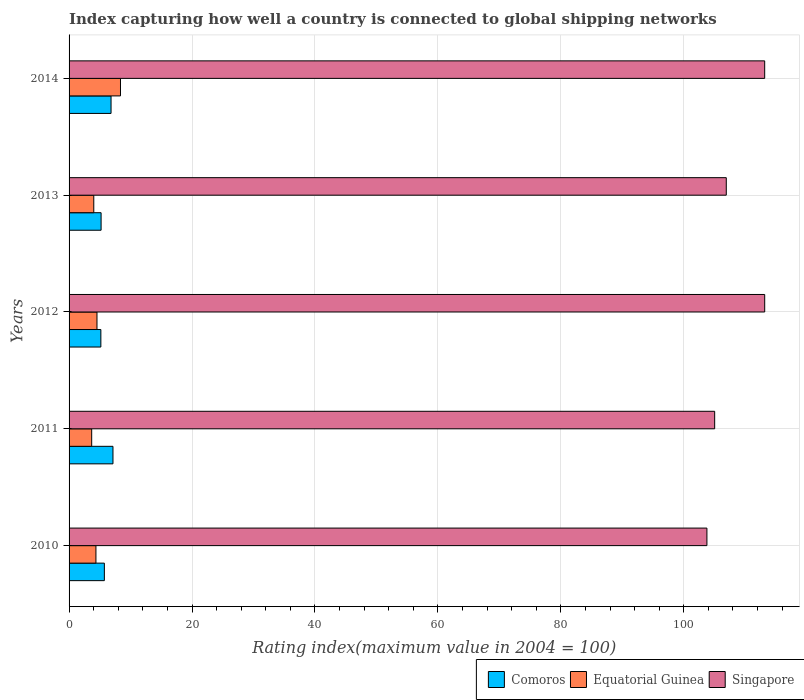How many different coloured bars are there?
Your answer should be compact. 3. Are the number of bars per tick equal to the number of legend labels?
Your answer should be very brief. Yes. How many bars are there on the 5th tick from the bottom?
Offer a very short reply. 3. What is the label of the 3rd group of bars from the top?
Provide a succinct answer. 2012. What is the rating index in Comoros in 2012?
Your answer should be compact. 5.17. Across all years, what is the maximum rating index in Singapore?
Give a very brief answer. 113.16. Across all years, what is the minimum rating index in Singapore?
Ensure brevity in your answer.  103.76. What is the total rating index in Singapore in the graph?
Ensure brevity in your answer.  542.01. What is the difference between the rating index in Comoros in 2010 and that in 2014?
Give a very brief answer. -1.09. What is the difference between the rating index in Equatorial Guinea in 2010 and the rating index in Singapore in 2014?
Make the answer very short. -108.79. What is the average rating index in Equatorial Guinea per year?
Your answer should be very brief. 4.99. In the year 2013, what is the difference between the rating index in Equatorial Guinea and rating index in Comoros?
Make the answer very short. -1.19. What is the ratio of the rating index in Comoros in 2010 to that in 2014?
Ensure brevity in your answer.  0.84. Is the difference between the rating index in Equatorial Guinea in 2011 and 2014 greater than the difference between the rating index in Comoros in 2011 and 2014?
Keep it short and to the point. No. What is the difference between the highest and the second highest rating index in Singapore?
Give a very brief answer. 0. What is the difference between the highest and the lowest rating index in Equatorial Guinea?
Make the answer very short. 4.68. In how many years, is the rating index in Comoros greater than the average rating index in Comoros taken over all years?
Make the answer very short. 2. Is the sum of the rating index in Equatorial Guinea in 2010 and 2011 greater than the maximum rating index in Singapore across all years?
Your answer should be compact. No. What does the 1st bar from the top in 2013 represents?
Offer a very short reply. Singapore. What does the 1st bar from the bottom in 2014 represents?
Offer a very short reply. Comoros. Is it the case that in every year, the sum of the rating index in Singapore and rating index in Equatorial Guinea is greater than the rating index in Comoros?
Provide a succinct answer. Yes. How many bars are there?
Your answer should be very brief. 15. What is the difference between two consecutive major ticks on the X-axis?
Your answer should be compact. 20. How are the legend labels stacked?
Offer a very short reply. Horizontal. What is the title of the graph?
Offer a terse response. Index capturing how well a country is connected to global shipping networks. What is the label or title of the X-axis?
Give a very brief answer. Rating index(maximum value in 2004 = 100). What is the Rating index(maximum value in 2004 = 100) of Comoros in 2010?
Your response must be concise. 5.74. What is the Rating index(maximum value in 2004 = 100) in Equatorial Guinea in 2010?
Provide a succinct answer. 4.37. What is the Rating index(maximum value in 2004 = 100) of Singapore in 2010?
Provide a short and direct response. 103.76. What is the Rating index(maximum value in 2004 = 100) of Comoros in 2011?
Ensure brevity in your answer.  7.14. What is the Rating index(maximum value in 2004 = 100) of Equatorial Guinea in 2011?
Your response must be concise. 3.68. What is the Rating index(maximum value in 2004 = 100) in Singapore in 2011?
Offer a terse response. 105.02. What is the Rating index(maximum value in 2004 = 100) of Comoros in 2012?
Make the answer very short. 5.17. What is the Rating index(maximum value in 2004 = 100) in Equatorial Guinea in 2012?
Make the answer very short. 4.54. What is the Rating index(maximum value in 2004 = 100) of Singapore in 2012?
Make the answer very short. 113.16. What is the Rating index(maximum value in 2004 = 100) of Comoros in 2013?
Provide a short and direct response. 5.21. What is the Rating index(maximum value in 2004 = 100) in Equatorial Guinea in 2013?
Your answer should be compact. 4.02. What is the Rating index(maximum value in 2004 = 100) in Singapore in 2013?
Your answer should be compact. 106.91. What is the Rating index(maximum value in 2004 = 100) of Comoros in 2014?
Keep it short and to the point. 6.83. What is the Rating index(maximum value in 2004 = 100) in Equatorial Guinea in 2014?
Keep it short and to the point. 8.36. What is the Rating index(maximum value in 2004 = 100) of Singapore in 2014?
Make the answer very short. 113.16. Across all years, what is the maximum Rating index(maximum value in 2004 = 100) in Comoros?
Ensure brevity in your answer.  7.14. Across all years, what is the maximum Rating index(maximum value in 2004 = 100) of Equatorial Guinea?
Make the answer very short. 8.36. Across all years, what is the maximum Rating index(maximum value in 2004 = 100) of Singapore?
Your answer should be very brief. 113.16. Across all years, what is the minimum Rating index(maximum value in 2004 = 100) in Comoros?
Your answer should be very brief. 5.17. Across all years, what is the minimum Rating index(maximum value in 2004 = 100) in Equatorial Guinea?
Provide a short and direct response. 3.68. Across all years, what is the minimum Rating index(maximum value in 2004 = 100) of Singapore?
Your answer should be compact. 103.76. What is the total Rating index(maximum value in 2004 = 100) of Comoros in the graph?
Provide a short and direct response. 30.09. What is the total Rating index(maximum value in 2004 = 100) in Equatorial Guinea in the graph?
Make the answer very short. 24.97. What is the total Rating index(maximum value in 2004 = 100) of Singapore in the graph?
Your answer should be compact. 542.01. What is the difference between the Rating index(maximum value in 2004 = 100) in Equatorial Guinea in 2010 and that in 2011?
Provide a succinct answer. 0.69. What is the difference between the Rating index(maximum value in 2004 = 100) in Singapore in 2010 and that in 2011?
Ensure brevity in your answer.  -1.26. What is the difference between the Rating index(maximum value in 2004 = 100) in Comoros in 2010 and that in 2012?
Your answer should be compact. 0.57. What is the difference between the Rating index(maximum value in 2004 = 100) of Equatorial Guinea in 2010 and that in 2012?
Keep it short and to the point. -0.17. What is the difference between the Rating index(maximum value in 2004 = 100) of Comoros in 2010 and that in 2013?
Your response must be concise. 0.53. What is the difference between the Rating index(maximum value in 2004 = 100) of Equatorial Guinea in 2010 and that in 2013?
Provide a succinct answer. 0.35. What is the difference between the Rating index(maximum value in 2004 = 100) of Singapore in 2010 and that in 2013?
Ensure brevity in your answer.  -3.15. What is the difference between the Rating index(maximum value in 2004 = 100) in Comoros in 2010 and that in 2014?
Offer a very short reply. -1.09. What is the difference between the Rating index(maximum value in 2004 = 100) of Equatorial Guinea in 2010 and that in 2014?
Ensure brevity in your answer.  -3.99. What is the difference between the Rating index(maximum value in 2004 = 100) of Singapore in 2010 and that in 2014?
Give a very brief answer. -9.4. What is the difference between the Rating index(maximum value in 2004 = 100) in Comoros in 2011 and that in 2012?
Your response must be concise. 1.97. What is the difference between the Rating index(maximum value in 2004 = 100) in Equatorial Guinea in 2011 and that in 2012?
Provide a short and direct response. -0.86. What is the difference between the Rating index(maximum value in 2004 = 100) in Singapore in 2011 and that in 2012?
Make the answer very short. -8.14. What is the difference between the Rating index(maximum value in 2004 = 100) of Comoros in 2011 and that in 2013?
Offer a terse response. 1.93. What is the difference between the Rating index(maximum value in 2004 = 100) in Equatorial Guinea in 2011 and that in 2013?
Provide a succinct answer. -0.34. What is the difference between the Rating index(maximum value in 2004 = 100) of Singapore in 2011 and that in 2013?
Offer a terse response. -1.89. What is the difference between the Rating index(maximum value in 2004 = 100) of Comoros in 2011 and that in 2014?
Your answer should be compact. 0.31. What is the difference between the Rating index(maximum value in 2004 = 100) of Equatorial Guinea in 2011 and that in 2014?
Make the answer very short. -4.68. What is the difference between the Rating index(maximum value in 2004 = 100) of Singapore in 2011 and that in 2014?
Give a very brief answer. -8.14. What is the difference between the Rating index(maximum value in 2004 = 100) in Comoros in 2012 and that in 2013?
Your answer should be very brief. -0.04. What is the difference between the Rating index(maximum value in 2004 = 100) of Equatorial Guinea in 2012 and that in 2013?
Offer a terse response. 0.52. What is the difference between the Rating index(maximum value in 2004 = 100) in Singapore in 2012 and that in 2013?
Keep it short and to the point. 6.25. What is the difference between the Rating index(maximum value in 2004 = 100) of Comoros in 2012 and that in 2014?
Your answer should be very brief. -1.66. What is the difference between the Rating index(maximum value in 2004 = 100) of Equatorial Guinea in 2012 and that in 2014?
Provide a short and direct response. -3.82. What is the difference between the Rating index(maximum value in 2004 = 100) of Singapore in 2012 and that in 2014?
Your response must be concise. 0. What is the difference between the Rating index(maximum value in 2004 = 100) in Comoros in 2013 and that in 2014?
Your response must be concise. -1.62. What is the difference between the Rating index(maximum value in 2004 = 100) in Equatorial Guinea in 2013 and that in 2014?
Provide a short and direct response. -4.34. What is the difference between the Rating index(maximum value in 2004 = 100) in Singapore in 2013 and that in 2014?
Make the answer very short. -6.25. What is the difference between the Rating index(maximum value in 2004 = 100) in Comoros in 2010 and the Rating index(maximum value in 2004 = 100) in Equatorial Guinea in 2011?
Make the answer very short. 2.06. What is the difference between the Rating index(maximum value in 2004 = 100) of Comoros in 2010 and the Rating index(maximum value in 2004 = 100) of Singapore in 2011?
Ensure brevity in your answer.  -99.28. What is the difference between the Rating index(maximum value in 2004 = 100) in Equatorial Guinea in 2010 and the Rating index(maximum value in 2004 = 100) in Singapore in 2011?
Make the answer very short. -100.65. What is the difference between the Rating index(maximum value in 2004 = 100) of Comoros in 2010 and the Rating index(maximum value in 2004 = 100) of Equatorial Guinea in 2012?
Your answer should be very brief. 1.2. What is the difference between the Rating index(maximum value in 2004 = 100) of Comoros in 2010 and the Rating index(maximum value in 2004 = 100) of Singapore in 2012?
Ensure brevity in your answer.  -107.42. What is the difference between the Rating index(maximum value in 2004 = 100) in Equatorial Guinea in 2010 and the Rating index(maximum value in 2004 = 100) in Singapore in 2012?
Keep it short and to the point. -108.79. What is the difference between the Rating index(maximum value in 2004 = 100) in Comoros in 2010 and the Rating index(maximum value in 2004 = 100) in Equatorial Guinea in 2013?
Offer a very short reply. 1.72. What is the difference between the Rating index(maximum value in 2004 = 100) in Comoros in 2010 and the Rating index(maximum value in 2004 = 100) in Singapore in 2013?
Your response must be concise. -101.17. What is the difference between the Rating index(maximum value in 2004 = 100) in Equatorial Guinea in 2010 and the Rating index(maximum value in 2004 = 100) in Singapore in 2013?
Ensure brevity in your answer.  -102.54. What is the difference between the Rating index(maximum value in 2004 = 100) of Comoros in 2010 and the Rating index(maximum value in 2004 = 100) of Equatorial Guinea in 2014?
Give a very brief answer. -2.62. What is the difference between the Rating index(maximum value in 2004 = 100) in Comoros in 2010 and the Rating index(maximum value in 2004 = 100) in Singapore in 2014?
Offer a very short reply. -107.42. What is the difference between the Rating index(maximum value in 2004 = 100) in Equatorial Guinea in 2010 and the Rating index(maximum value in 2004 = 100) in Singapore in 2014?
Give a very brief answer. -108.79. What is the difference between the Rating index(maximum value in 2004 = 100) of Comoros in 2011 and the Rating index(maximum value in 2004 = 100) of Equatorial Guinea in 2012?
Your answer should be compact. 2.6. What is the difference between the Rating index(maximum value in 2004 = 100) in Comoros in 2011 and the Rating index(maximum value in 2004 = 100) in Singapore in 2012?
Offer a terse response. -106.02. What is the difference between the Rating index(maximum value in 2004 = 100) of Equatorial Guinea in 2011 and the Rating index(maximum value in 2004 = 100) of Singapore in 2012?
Give a very brief answer. -109.48. What is the difference between the Rating index(maximum value in 2004 = 100) of Comoros in 2011 and the Rating index(maximum value in 2004 = 100) of Equatorial Guinea in 2013?
Provide a succinct answer. 3.12. What is the difference between the Rating index(maximum value in 2004 = 100) of Comoros in 2011 and the Rating index(maximum value in 2004 = 100) of Singapore in 2013?
Your response must be concise. -99.77. What is the difference between the Rating index(maximum value in 2004 = 100) in Equatorial Guinea in 2011 and the Rating index(maximum value in 2004 = 100) in Singapore in 2013?
Offer a very short reply. -103.23. What is the difference between the Rating index(maximum value in 2004 = 100) of Comoros in 2011 and the Rating index(maximum value in 2004 = 100) of Equatorial Guinea in 2014?
Your response must be concise. -1.22. What is the difference between the Rating index(maximum value in 2004 = 100) of Comoros in 2011 and the Rating index(maximum value in 2004 = 100) of Singapore in 2014?
Your answer should be very brief. -106.02. What is the difference between the Rating index(maximum value in 2004 = 100) of Equatorial Guinea in 2011 and the Rating index(maximum value in 2004 = 100) of Singapore in 2014?
Offer a terse response. -109.48. What is the difference between the Rating index(maximum value in 2004 = 100) of Comoros in 2012 and the Rating index(maximum value in 2004 = 100) of Equatorial Guinea in 2013?
Offer a terse response. 1.15. What is the difference between the Rating index(maximum value in 2004 = 100) of Comoros in 2012 and the Rating index(maximum value in 2004 = 100) of Singapore in 2013?
Ensure brevity in your answer.  -101.74. What is the difference between the Rating index(maximum value in 2004 = 100) of Equatorial Guinea in 2012 and the Rating index(maximum value in 2004 = 100) of Singapore in 2013?
Ensure brevity in your answer.  -102.37. What is the difference between the Rating index(maximum value in 2004 = 100) of Comoros in 2012 and the Rating index(maximum value in 2004 = 100) of Equatorial Guinea in 2014?
Your answer should be compact. -3.19. What is the difference between the Rating index(maximum value in 2004 = 100) of Comoros in 2012 and the Rating index(maximum value in 2004 = 100) of Singapore in 2014?
Offer a terse response. -107.99. What is the difference between the Rating index(maximum value in 2004 = 100) of Equatorial Guinea in 2012 and the Rating index(maximum value in 2004 = 100) of Singapore in 2014?
Make the answer very short. -108.62. What is the difference between the Rating index(maximum value in 2004 = 100) of Comoros in 2013 and the Rating index(maximum value in 2004 = 100) of Equatorial Guinea in 2014?
Make the answer very short. -3.15. What is the difference between the Rating index(maximum value in 2004 = 100) of Comoros in 2013 and the Rating index(maximum value in 2004 = 100) of Singapore in 2014?
Keep it short and to the point. -107.95. What is the difference between the Rating index(maximum value in 2004 = 100) of Equatorial Guinea in 2013 and the Rating index(maximum value in 2004 = 100) of Singapore in 2014?
Offer a very short reply. -109.14. What is the average Rating index(maximum value in 2004 = 100) of Comoros per year?
Provide a short and direct response. 6.02. What is the average Rating index(maximum value in 2004 = 100) of Equatorial Guinea per year?
Keep it short and to the point. 4.99. What is the average Rating index(maximum value in 2004 = 100) of Singapore per year?
Your response must be concise. 108.4. In the year 2010, what is the difference between the Rating index(maximum value in 2004 = 100) of Comoros and Rating index(maximum value in 2004 = 100) of Equatorial Guinea?
Offer a very short reply. 1.37. In the year 2010, what is the difference between the Rating index(maximum value in 2004 = 100) of Comoros and Rating index(maximum value in 2004 = 100) of Singapore?
Ensure brevity in your answer.  -98.02. In the year 2010, what is the difference between the Rating index(maximum value in 2004 = 100) in Equatorial Guinea and Rating index(maximum value in 2004 = 100) in Singapore?
Offer a very short reply. -99.39. In the year 2011, what is the difference between the Rating index(maximum value in 2004 = 100) in Comoros and Rating index(maximum value in 2004 = 100) in Equatorial Guinea?
Your answer should be compact. 3.46. In the year 2011, what is the difference between the Rating index(maximum value in 2004 = 100) of Comoros and Rating index(maximum value in 2004 = 100) of Singapore?
Your answer should be very brief. -97.88. In the year 2011, what is the difference between the Rating index(maximum value in 2004 = 100) in Equatorial Guinea and Rating index(maximum value in 2004 = 100) in Singapore?
Your answer should be very brief. -101.34. In the year 2012, what is the difference between the Rating index(maximum value in 2004 = 100) of Comoros and Rating index(maximum value in 2004 = 100) of Equatorial Guinea?
Provide a short and direct response. 0.63. In the year 2012, what is the difference between the Rating index(maximum value in 2004 = 100) of Comoros and Rating index(maximum value in 2004 = 100) of Singapore?
Your response must be concise. -107.99. In the year 2012, what is the difference between the Rating index(maximum value in 2004 = 100) in Equatorial Guinea and Rating index(maximum value in 2004 = 100) in Singapore?
Your response must be concise. -108.62. In the year 2013, what is the difference between the Rating index(maximum value in 2004 = 100) of Comoros and Rating index(maximum value in 2004 = 100) of Equatorial Guinea?
Give a very brief answer. 1.19. In the year 2013, what is the difference between the Rating index(maximum value in 2004 = 100) of Comoros and Rating index(maximum value in 2004 = 100) of Singapore?
Offer a very short reply. -101.7. In the year 2013, what is the difference between the Rating index(maximum value in 2004 = 100) in Equatorial Guinea and Rating index(maximum value in 2004 = 100) in Singapore?
Your answer should be compact. -102.89. In the year 2014, what is the difference between the Rating index(maximum value in 2004 = 100) in Comoros and Rating index(maximum value in 2004 = 100) in Equatorial Guinea?
Your answer should be compact. -1.54. In the year 2014, what is the difference between the Rating index(maximum value in 2004 = 100) of Comoros and Rating index(maximum value in 2004 = 100) of Singapore?
Your answer should be compact. -106.33. In the year 2014, what is the difference between the Rating index(maximum value in 2004 = 100) in Equatorial Guinea and Rating index(maximum value in 2004 = 100) in Singapore?
Offer a terse response. -104.79. What is the ratio of the Rating index(maximum value in 2004 = 100) in Comoros in 2010 to that in 2011?
Make the answer very short. 0.8. What is the ratio of the Rating index(maximum value in 2004 = 100) in Equatorial Guinea in 2010 to that in 2011?
Make the answer very short. 1.19. What is the ratio of the Rating index(maximum value in 2004 = 100) of Singapore in 2010 to that in 2011?
Give a very brief answer. 0.99. What is the ratio of the Rating index(maximum value in 2004 = 100) in Comoros in 2010 to that in 2012?
Your answer should be compact. 1.11. What is the ratio of the Rating index(maximum value in 2004 = 100) in Equatorial Guinea in 2010 to that in 2012?
Your response must be concise. 0.96. What is the ratio of the Rating index(maximum value in 2004 = 100) in Singapore in 2010 to that in 2012?
Provide a succinct answer. 0.92. What is the ratio of the Rating index(maximum value in 2004 = 100) of Comoros in 2010 to that in 2013?
Ensure brevity in your answer.  1.1. What is the ratio of the Rating index(maximum value in 2004 = 100) of Equatorial Guinea in 2010 to that in 2013?
Offer a terse response. 1.09. What is the ratio of the Rating index(maximum value in 2004 = 100) in Singapore in 2010 to that in 2013?
Your answer should be very brief. 0.97. What is the ratio of the Rating index(maximum value in 2004 = 100) of Comoros in 2010 to that in 2014?
Keep it short and to the point. 0.84. What is the ratio of the Rating index(maximum value in 2004 = 100) in Equatorial Guinea in 2010 to that in 2014?
Your answer should be compact. 0.52. What is the ratio of the Rating index(maximum value in 2004 = 100) in Singapore in 2010 to that in 2014?
Give a very brief answer. 0.92. What is the ratio of the Rating index(maximum value in 2004 = 100) in Comoros in 2011 to that in 2012?
Offer a terse response. 1.38. What is the ratio of the Rating index(maximum value in 2004 = 100) of Equatorial Guinea in 2011 to that in 2012?
Provide a succinct answer. 0.81. What is the ratio of the Rating index(maximum value in 2004 = 100) in Singapore in 2011 to that in 2012?
Offer a terse response. 0.93. What is the ratio of the Rating index(maximum value in 2004 = 100) in Comoros in 2011 to that in 2013?
Offer a terse response. 1.37. What is the ratio of the Rating index(maximum value in 2004 = 100) in Equatorial Guinea in 2011 to that in 2013?
Give a very brief answer. 0.92. What is the ratio of the Rating index(maximum value in 2004 = 100) of Singapore in 2011 to that in 2013?
Provide a succinct answer. 0.98. What is the ratio of the Rating index(maximum value in 2004 = 100) of Comoros in 2011 to that in 2014?
Your answer should be very brief. 1.05. What is the ratio of the Rating index(maximum value in 2004 = 100) of Equatorial Guinea in 2011 to that in 2014?
Offer a very short reply. 0.44. What is the ratio of the Rating index(maximum value in 2004 = 100) of Singapore in 2011 to that in 2014?
Make the answer very short. 0.93. What is the ratio of the Rating index(maximum value in 2004 = 100) of Comoros in 2012 to that in 2013?
Provide a succinct answer. 0.99. What is the ratio of the Rating index(maximum value in 2004 = 100) of Equatorial Guinea in 2012 to that in 2013?
Your answer should be compact. 1.13. What is the ratio of the Rating index(maximum value in 2004 = 100) in Singapore in 2012 to that in 2013?
Keep it short and to the point. 1.06. What is the ratio of the Rating index(maximum value in 2004 = 100) in Comoros in 2012 to that in 2014?
Offer a very short reply. 0.76. What is the ratio of the Rating index(maximum value in 2004 = 100) in Equatorial Guinea in 2012 to that in 2014?
Your answer should be very brief. 0.54. What is the ratio of the Rating index(maximum value in 2004 = 100) in Singapore in 2012 to that in 2014?
Give a very brief answer. 1. What is the ratio of the Rating index(maximum value in 2004 = 100) in Comoros in 2013 to that in 2014?
Offer a terse response. 0.76. What is the ratio of the Rating index(maximum value in 2004 = 100) in Equatorial Guinea in 2013 to that in 2014?
Offer a terse response. 0.48. What is the ratio of the Rating index(maximum value in 2004 = 100) of Singapore in 2013 to that in 2014?
Offer a very short reply. 0.94. What is the difference between the highest and the second highest Rating index(maximum value in 2004 = 100) in Comoros?
Offer a terse response. 0.31. What is the difference between the highest and the second highest Rating index(maximum value in 2004 = 100) of Equatorial Guinea?
Your answer should be compact. 3.82. What is the difference between the highest and the second highest Rating index(maximum value in 2004 = 100) in Singapore?
Provide a succinct answer. 0. What is the difference between the highest and the lowest Rating index(maximum value in 2004 = 100) in Comoros?
Keep it short and to the point. 1.97. What is the difference between the highest and the lowest Rating index(maximum value in 2004 = 100) of Equatorial Guinea?
Give a very brief answer. 4.68. What is the difference between the highest and the lowest Rating index(maximum value in 2004 = 100) in Singapore?
Ensure brevity in your answer.  9.4. 